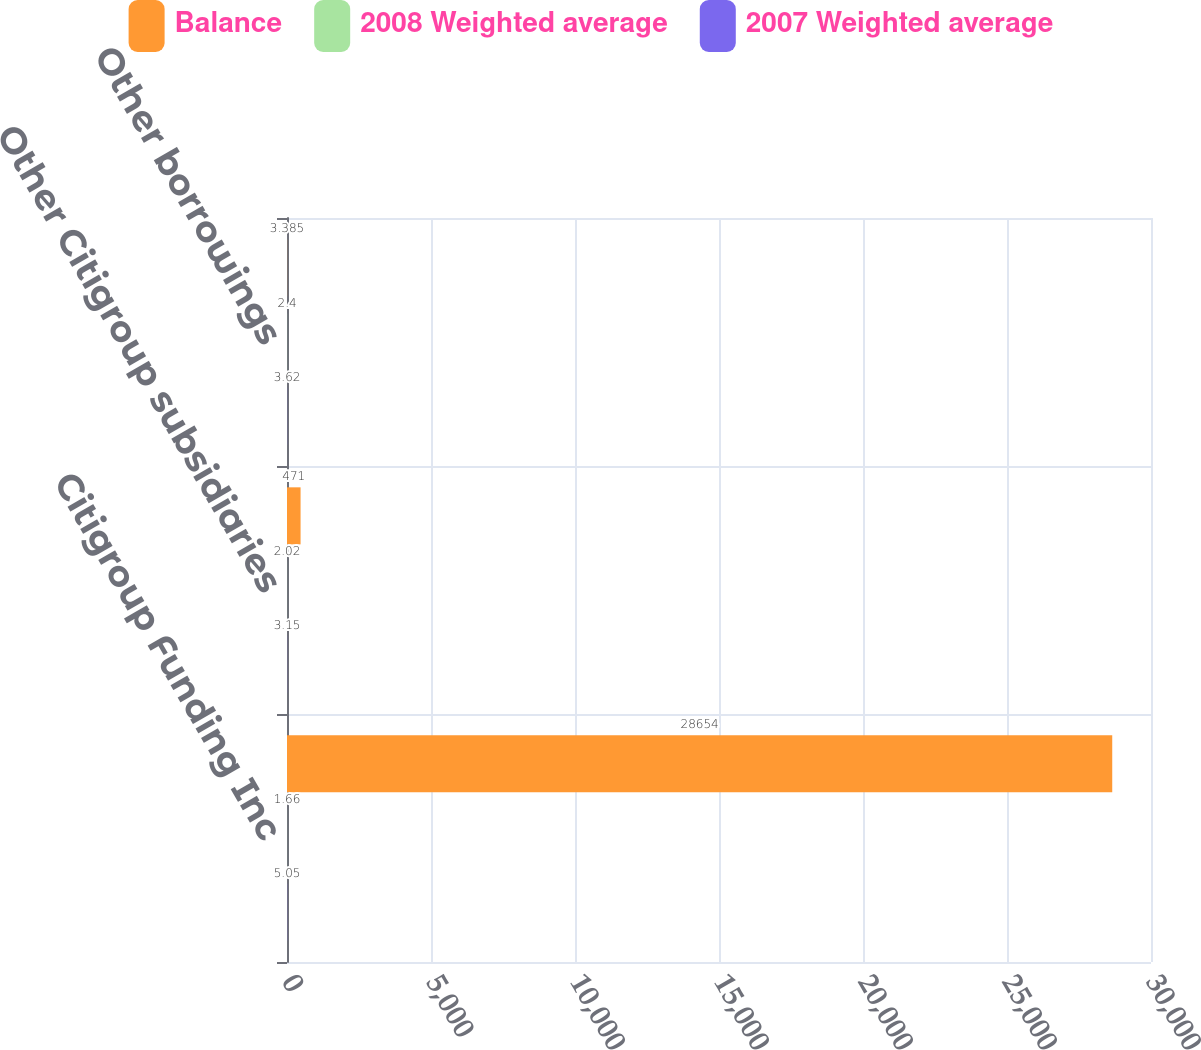Convert chart. <chart><loc_0><loc_0><loc_500><loc_500><stacked_bar_chart><ecel><fcel>Citigroup Funding Inc<fcel>Other Citigroup subsidiaries<fcel>Other borrowings<nl><fcel>Balance<fcel>28654<fcel>471<fcel>3.385<nl><fcel>2008 Weighted average<fcel>1.66<fcel>2.02<fcel>2.4<nl><fcel>2007 Weighted average<fcel>5.05<fcel>3.15<fcel>3.62<nl></chart> 